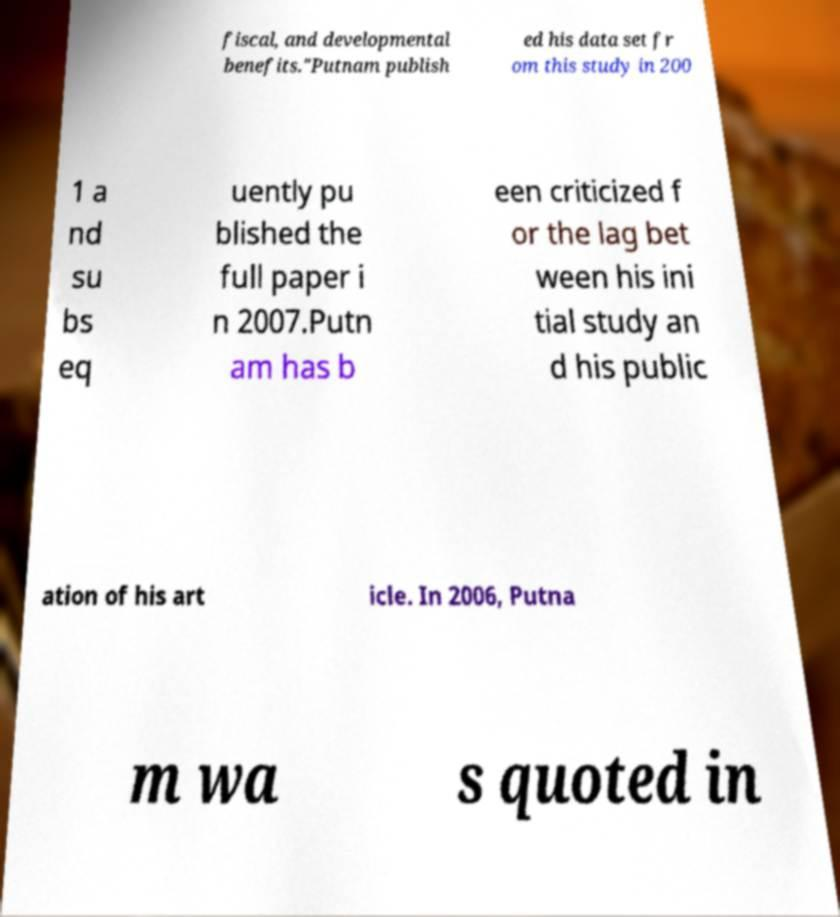Could you extract and type out the text from this image? fiscal, and developmental benefits."Putnam publish ed his data set fr om this study in 200 1 a nd su bs eq uently pu blished the full paper i n 2007.Putn am has b een criticized f or the lag bet ween his ini tial study an d his public ation of his art icle. In 2006, Putna m wa s quoted in 